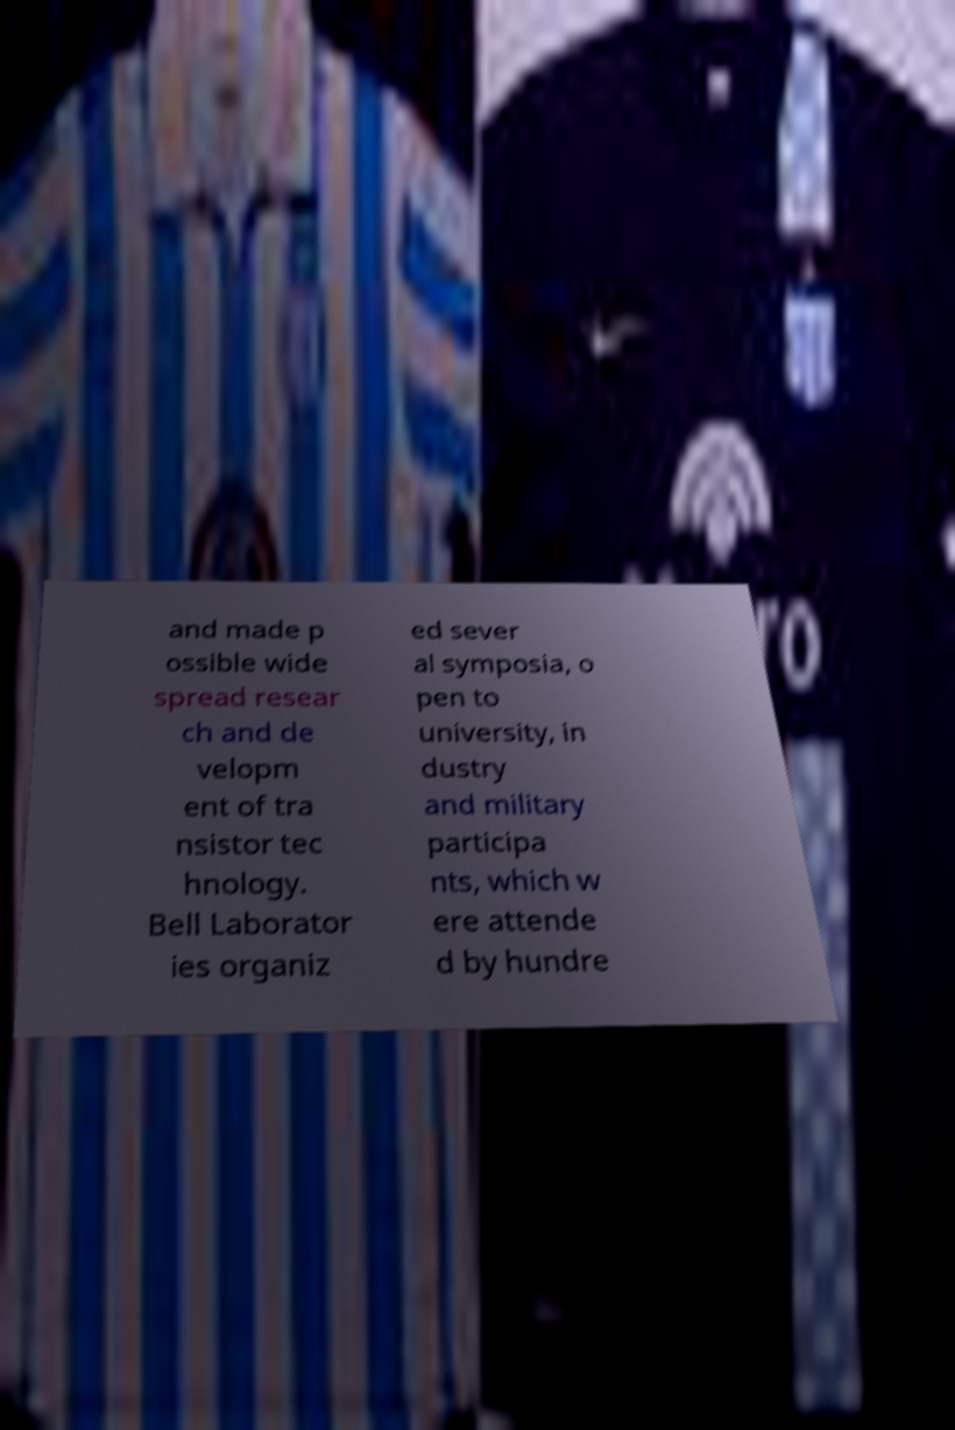Could you assist in decoding the text presented in this image and type it out clearly? and made p ossible wide spread resear ch and de velopm ent of tra nsistor tec hnology. Bell Laborator ies organiz ed sever al symposia, o pen to university, in dustry and military participa nts, which w ere attende d by hundre 